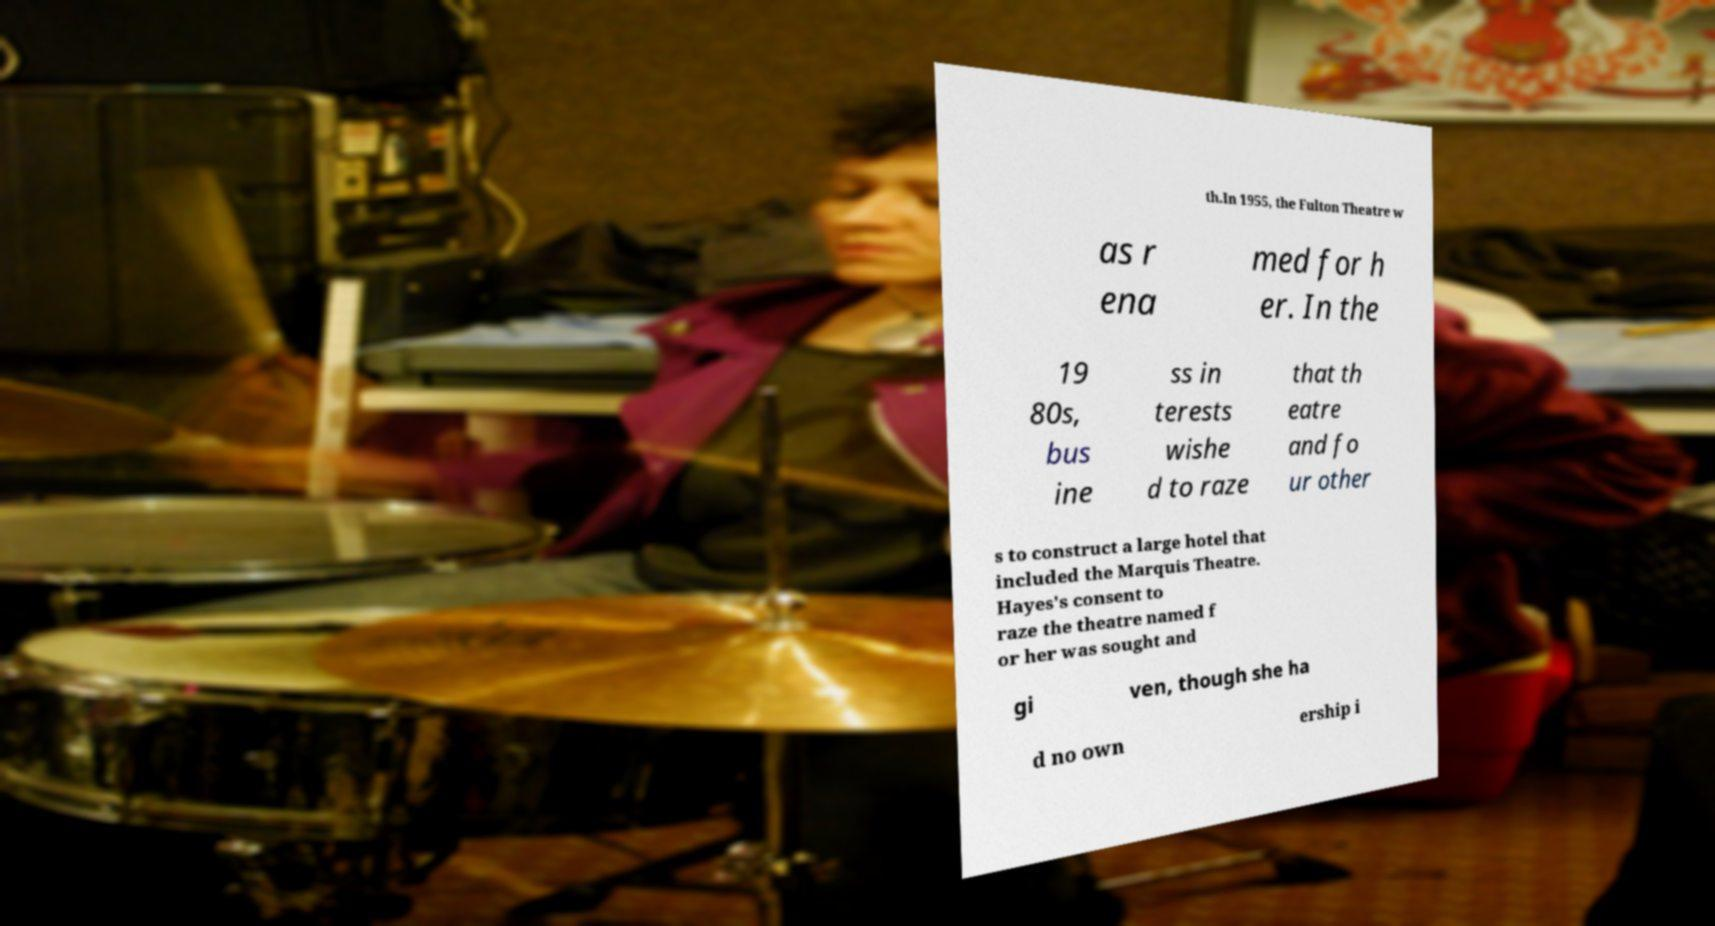Could you assist in decoding the text presented in this image and type it out clearly? th.In 1955, the Fulton Theatre w as r ena med for h er. In the 19 80s, bus ine ss in terests wishe d to raze that th eatre and fo ur other s to construct a large hotel that included the Marquis Theatre. Hayes's consent to raze the theatre named f or her was sought and gi ven, though she ha d no own ership i 